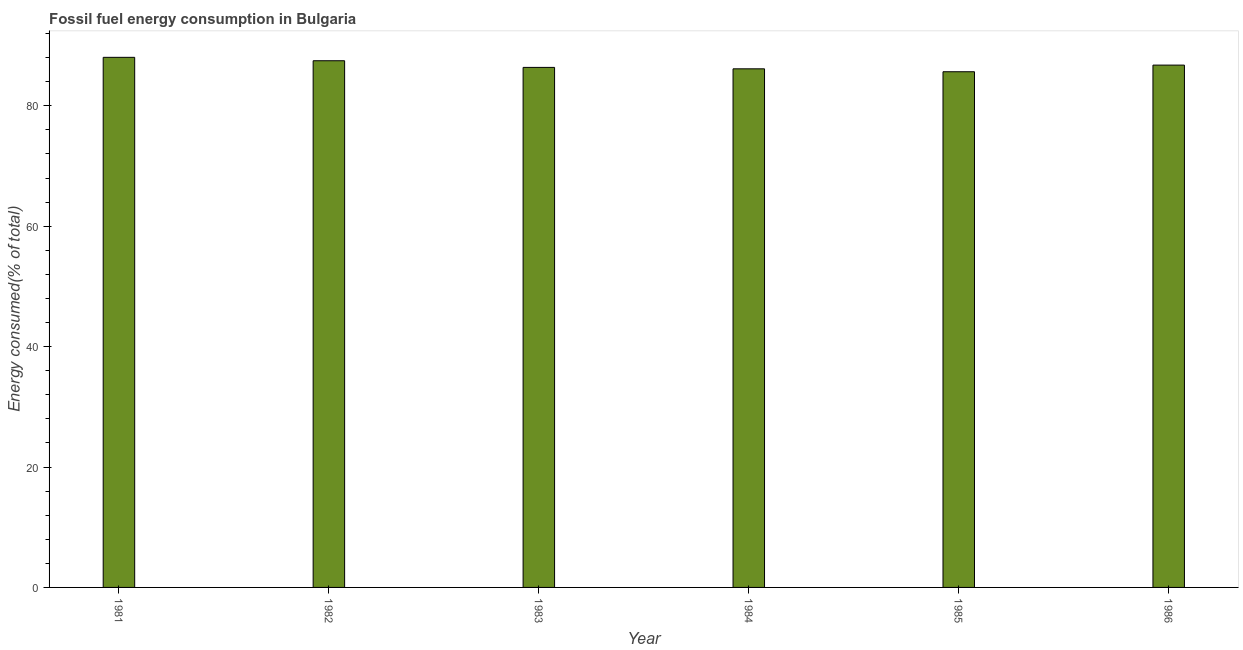Does the graph contain any zero values?
Your answer should be compact. No. What is the title of the graph?
Ensure brevity in your answer.  Fossil fuel energy consumption in Bulgaria. What is the label or title of the X-axis?
Your response must be concise. Year. What is the label or title of the Y-axis?
Your answer should be very brief. Energy consumed(% of total). What is the fossil fuel energy consumption in 1982?
Give a very brief answer. 87.48. Across all years, what is the maximum fossil fuel energy consumption?
Give a very brief answer. 88.04. Across all years, what is the minimum fossil fuel energy consumption?
Make the answer very short. 85.65. In which year was the fossil fuel energy consumption minimum?
Your answer should be compact. 1985. What is the sum of the fossil fuel energy consumption?
Give a very brief answer. 520.44. What is the difference between the fossil fuel energy consumption in 1983 and 1985?
Give a very brief answer. 0.72. What is the average fossil fuel energy consumption per year?
Keep it short and to the point. 86.74. What is the median fossil fuel energy consumption?
Your response must be concise. 86.56. In how many years, is the fossil fuel energy consumption greater than 12 %?
Your answer should be very brief. 6. Do a majority of the years between 1985 and 1983 (inclusive) have fossil fuel energy consumption greater than 4 %?
Your answer should be very brief. Yes. What is the ratio of the fossil fuel energy consumption in 1983 to that in 1984?
Offer a very short reply. 1. What is the difference between the highest and the second highest fossil fuel energy consumption?
Your answer should be very brief. 0.57. Is the sum of the fossil fuel energy consumption in 1982 and 1984 greater than the maximum fossil fuel energy consumption across all years?
Your response must be concise. Yes. What is the difference between the highest and the lowest fossil fuel energy consumption?
Offer a very short reply. 2.39. In how many years, is the fossil fuel energy consumption greater than the average fossil fuel energy consumption taken over all years?
Offer a terse response. 3. How many bars are there?
Your response must be concise. 6. How many years are there in the graph?
Your answer should be very brief. 6. What is the difference between two consecutive major ticks on the Y-axis?
Provide a short and direct response. 20. Are the values on the major ticks of Y-axis written in scientific E-notation?
Your answer should be very brief. No. What is the Energy consumed(% of total) of 1981?
Your answer should be compact. 88.04. What is the Energy consumed(% of total) in 1982?
Keep it short and to the point. 87.48. What is the Energy consumed(% of total) of 1983?
Keep it short and to the point. 86.37. What is the Energy consumed(% of total) of 1984?
Provide a succinct answer. 86.14. What is the Energy consumed(% of total) in 1985?
Offer a terse response. 85.65. What is the Energy consumed(% of total) in 1986?
Offer a terse response. 86.75. What is the difference between the Energy consumed(% of total) in 1981 and 1982?
Keep it short and to the point. 0.57. What is the difference between the Energy consumed(% of total) in 1981 and 1983?
Ensure brevity in your answer.  1.67. What is the difference between the Energy consumed(% of total) in 1981 and 1984?
Your response must be concise. 1.91. What is the difference between the Energy consumed(% of total) in 1981 and 1985?
Provide a short and direct response. 2.39. What is the difference between the Energy consumed(% of total) in 1981 and 1986?
Keep it short and to the point. 1.29. What is the difference between the Energy consumed(% of total) in 1982 and 1983?
Provide a succinct answer. 1.1. What is the difference between the Energy consumed(% of total) in 1982 and 1984?
Give a very brief answer. 1.34. What is the difference between the Energy consumed(% of total) in 1982 and 1985?
Provide a succinct answer. 1.83. What is the difference between the Energy consumed(% of total) in 1982 and 1986?
Your answer should be compact. 0.72. What is the difference between the Energy consumed(% of total) in 1983 and 1984?
Ensure brevity in your answer.  0.24. What is the difference between the Energy consumed(% of total) in 1983 and 1985?
Your answer should be compact. 0.72. What is the difference between the Energy consumed(% of total) in 1983 and 1986?
Your response must be concise. -0.38. What is the difference between the Energy consumed(% of total) in 1984 and 1985?
Give a very brief answer. 0.49. What is the difference between the Energy consumed(% of total) in 1984 and 1986?
Your answer should be very brief. -0.62. What is the difference between the Energy consumed(% of total) in 1985 and 1986?
Offer a very short reply. -1.1. What is the ratio of the Energy consumed(% of total) in 1981 to that in 1985?
Make the answer very short. 1.03. What is the ratio of the Energy consumed(% of total) in 1982 to that in 1984?
Provide a short and direct response. 1.02. What is the ratio of the Energy consumed(% of total) in 1983 to that in 1985?
Provide a short and direct response. 1.01. What is the ratio of the Energy consumed(% of total) in 1983 to that in 1986?
Offer a very short reply. 1. What is the ratio of the Energy consumed(% of total) in 1984 to that in 1986?
Offer a terse response. 0.99. 